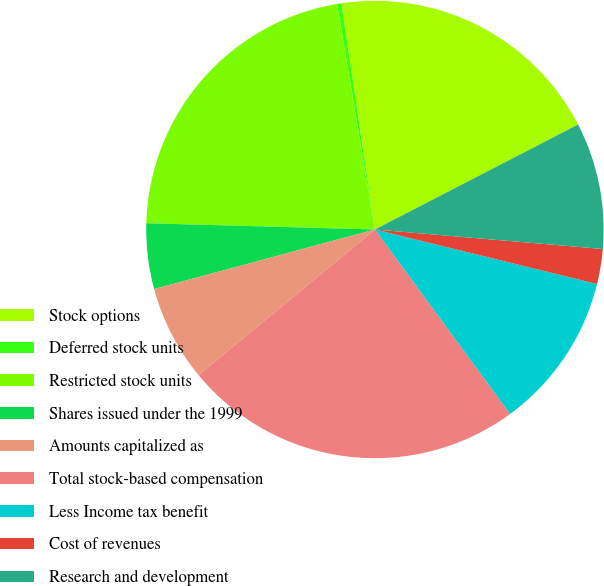<chart> <loc_0><loc_0><loc_500><loc_500><pie_chart><fcel>Stock options<fcel>Deferred stock units<fcel>Restricted stock units<fcel>Shares issued under the 1999<fcel>Amounts capitalized as<fcel>Total stock-based compensation<fcel>Less Income tax benefit<fcel>Cost of revenues<fcel>Research and development<nl><fcel>19.76%<fcel>0.3%<fcel>21.92%<fcel>4.63%<fcel>6.79%<fcel>24.08%<fcel>11.11%<fcel>2.47%<fcel>8.95%<nl></chart> 